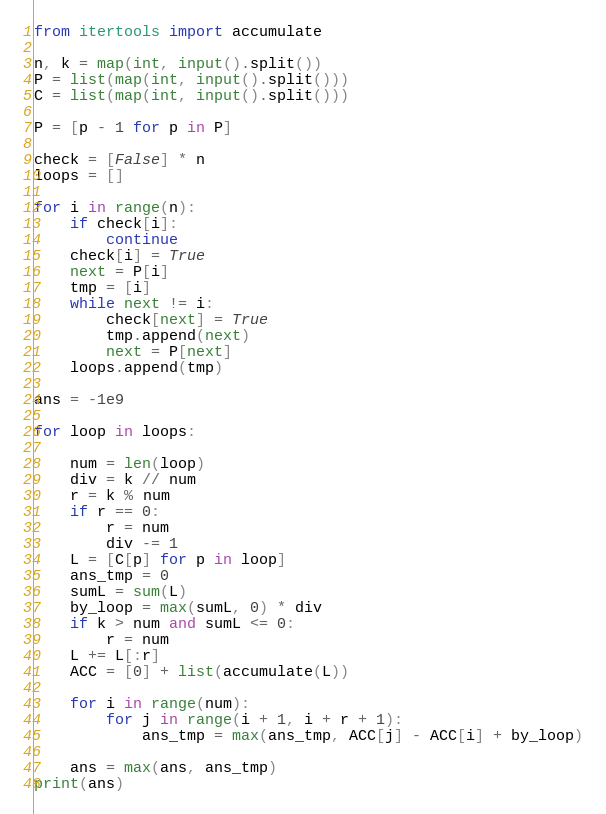Convert code to text. <code><loc_0><loc_0><loc_500><loc_500><_Python_>from itertools import accumulate

n, k = map(int, input().split())
P = list(map(int, input().split()))
C = list(map(int, input().split()))

P = [p - 1 for p in P]

check = [False] * n
loops = []

for i in range(n):
    if check[i]:
        continue
    check[i] = True
    next = P[i]
    tmp = [i]
    while next != i:
        check[next] = True
        tmp.append(next)
        next = P[next]
    loops.append(tmp)

ans = -1e9

for loop in loops:

    num = len(loop)
    div = k // num
    r = k % num
    if r == 0:
        r = num
        div -= 1
    L = [C[p] for p in loop]
    ans_tmp = 0
    sumL = sum(L)
    by_loop = max(sumL, 0) * div
    if k > num and sumL <= 0:
        r = num
    L += L[:r]
    ACC = [0] + list(accumulate(L))

    for i in range(num):
        for j in range(i + 1, i + r + 1):
            ans_tmp = max(ans_tmp, ACC[j] - ACC[i] + by_loop)

    ans = max(ans, ans_tmp)
print(ans)</code> 